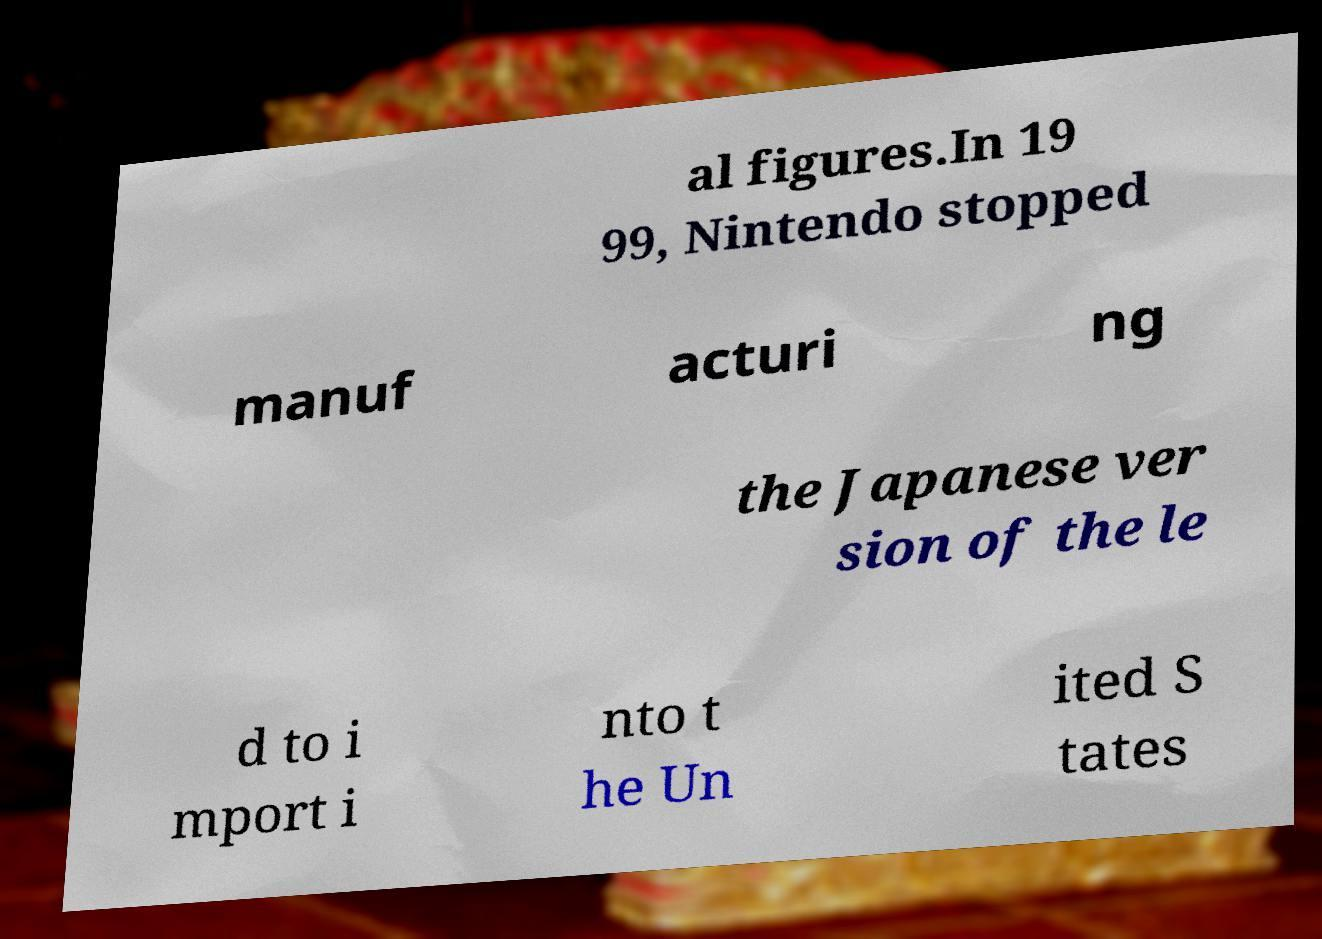Can you read and provide the text displayed in the image?This photo seems to have some interesting text. Can you extract and type it out for me? al figures.In 19 99, Nintendo stopped manuf acturi ng the Japanese ver sion of the le d to i mport i nto t he Un ited S tates 